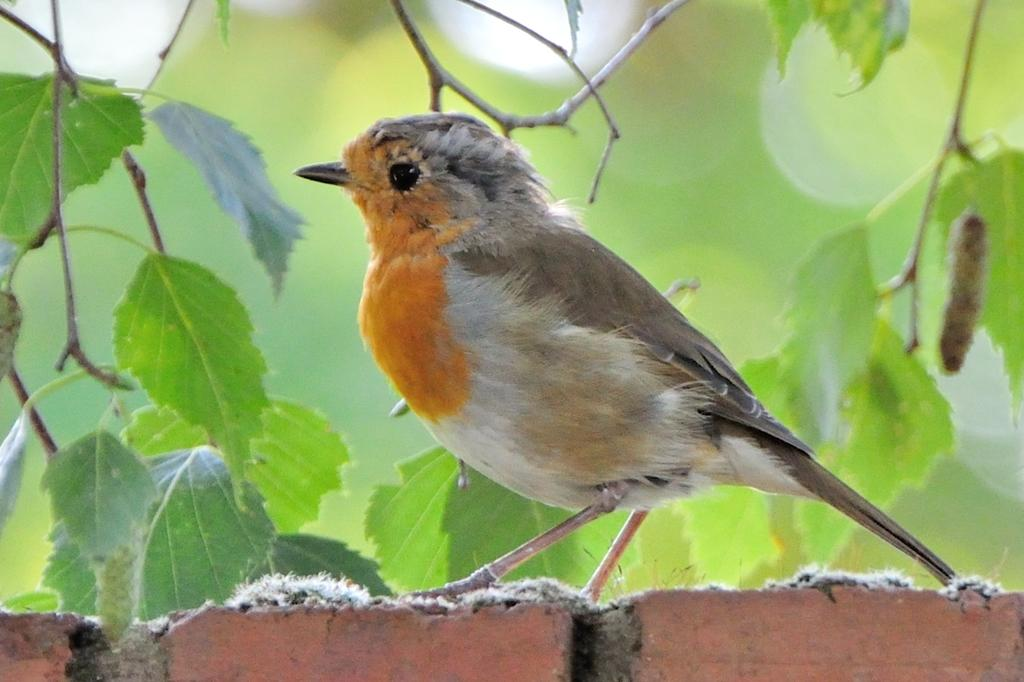What type of animal can be seen in the image? There is a bird in the image. Where is the bird located? The bird is sitting on a wall. What type of vegetation is visible in the image? There are green leaves visible in the image. What type of curtain can be seen hanging from the bird's beak in the image? There is no curtain present in the image, and the bird's beak is not holding anything. 